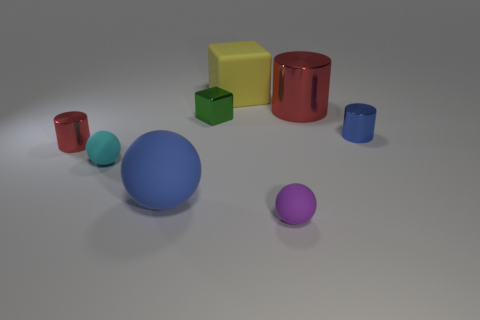How many red cylinders must be subtracted to get 1 red cylinders? 1 Subtract all big red metal cylinders. How many cylinders are left? 2 Subtract all cyan spheres. How many red cylinders are left? 2 Subtract 1 cylinders. How many cylinders are left? 2 Add 1 small matte objects. How many objects exist? 9 Add 5 tiny cyan matte things. How many tiny cyan matte things exist? 6 Subtract 0 green cylinders. How many objects are left? 8 Subtract all cubes. How many objects are left? 6 Subtract all brown cylinders. Subtract all brown cubes. How many cylinders are left? 3 Subtract all big metallic things. Subtract all gray shiny things. How many objects are left? 7 